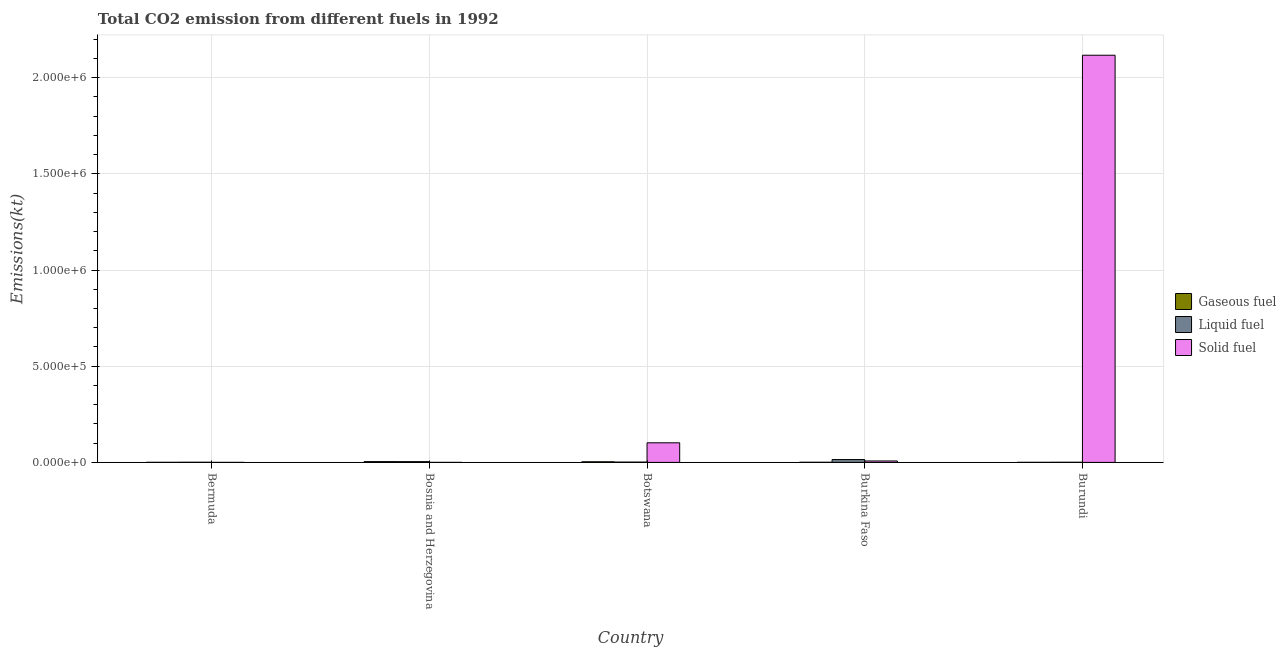How many different coloured bars are there?
Your answer should be very brief. 3. How many groups of bars are there?
Your answer should be very brief. 5. What is the label of the 3rd group of bars from the left?
Your answer should be very brief. Botswana. In how many cases, is the number of bars for a given country not equal to the number of legend labels?
Your answer should be compact. 0. What is the amount of co2 emissions from gaseous fuel in Burkina Faso?
Keep it short and to the point. 630.72. Across all countries, what is the maximum amount of co2 emissions from liquid fuel?
Offer a very short reply. 1.48e+04. Across all countries, what is the minimum amount of co2 emissions from liquid fuel?
Your response must be concise. 630.72. In which country was the amount of co2 emissions from gaseous fuel maximum?
Offer a very short reply. Bosnia and Herzegovina. In which country was the amount of co2 emissions from solid fuel minimum?
Give a very brief answer. Bosnia and Herzegovina. What is the total amount of co2 emissions from liquid fuel in the graph?
Keep it short and to the point. 2.17e+04. What is the difference between the amount of co2 emissions from gaseous fuel in Botswana and that in Burundi?
Your answer should be compact. 2966.6. What is the difference between the amount of co2 emissions from gaseous fuel in Bermuda and the amount of co2 emissions from liquid fuel in Botswana?
Offer a very short reply. -1188.11. What is the average amount of co2 emissions from liquid fuel per country?
Provide a succinct answer. 4331.46. What is the difference between the amount of co2 emissions from liquid fuel and amount of co2 emissions from solid fuel in Burundi?
Offer a very short reply. -2.12e+06. In how many countries, is the amount of co2 emissions from liquid fuel greater than 900000 kt?
Provide a short and direct response. 0. What is the ratio of the amount of co2 emissions from liquid fuel in Botswana to that in Burkina Faso?
Your answer should be compact. 0.11. Is the difference between the amount of co2 emissions from gaseous fuel in Bermuda and Burundi greater than the difference between the amount of co2 emissions from liquid fuel in Bermuda and Burundi?
Offer a very short reply. Yes. What is the difference between the highest and the second highest amount of co2 emissions from liquid fuel?
Your answer should be very brief. 1.08e+04. What is the difference between the highest and the lowest amount of co2 emissions from solid fuel?
Your response must be concise. 2.12e+06. In how many countries, is the amount of co2 emissions from gaseous fuel greater than the average amount of co2 emissions from gaseous fuel taken over all countries?
Provide a short and direct response. 2. What does the 1st bar from the left in Burundi represents?
Provide a short and direct response. Gaseous fuel. What does the 2nd bar from the right in Bermuda represents?
Offer a terse response. Liquid fuel. Is it the case that in every country, the sum of the amount of co2 emissions from gaseous fuel and amount of co2 emissions from liquid fuel is greater than the amount of co2 emissions from solid fuel?
Offer a very short reply. No. How many countries are there in the graph?
Keep it short and to the point. 5. What is the difference between two consecutive major ticks on the Y-axis?
Offer a terse response. 5.00e+05. Does the graph contain any zero values?
Your answer should be compact. No. Where does the legend appear in the graph?
Keep it short and to the point. Center right. How are the legend labels stacked?
Offer a very short reply. Vertical. What is the title of the graph?
Keep it short and to the point. Total CO2 emission from different fuels in 1992. Does "Ages 0-14" appear as one of the legend labels in the graph?
Offer a terse response. No. What is the label or title of the Y-axis?
Provide a short and direct response. Emissions(kt). What is the Emissions(kt) in Gaseous fuel in Bermuda?
Provide a short and direct response. 407.04. What is the Emissions(kt) in Liquid fuel in Bermuda?
Offer a very short reply. 722.4. What is the Emissions(kt) in Solid fuel in Bermuda?
Ensure brevity in your answer.  18.34. What is the Emissions(kt) of Gaseous fuel in Bosnia and Herzegovina?
Keep it short and to the point. 4136.38. What is the Emissions(kt) of Liquid fuel in Bosnia and Herzegovina?
Offer a very short reply. 3949.36. What is the Emissions(kt) in Solid fuel in Bosnia and Herzegovina?
Provide a succinct answer. 3.67. What is the Emissions(kt) of Gaseous fuel in Botswana?
Your answer should be very brief. 3274.63. What is the Emissions(kt) of Liquid fuel in Botswana?
Make the answer very short. 1595.14. What is the Emissions(kt) of Solid fuel in Botswana?
Your response must be concise. 1.02e+05. What is the Emissions(kt) of Gaseous fuel in Burkina Faso?
Your answer should be compact. 630.72. What is the Emissions(kt) in Liquid fuel in Burkina Faso?
Ensure brevity in your answer.  1.48e+04. What is the Emissions(kt) of Solid fuel in Burkina Faso?
Offer a very short reply. 7462.35. What is the Emissions(kt) in Gaseous fuel in Burundi?
Give a very brief answer. 308.03. What is the Emissions(kt) of Liquid fuel in Burundi?
Make the answer very short. 630.72. What is the Emissions(kt) of Solid fuel in Burundi?
Your answer should be compact. 2.12e+06. Across all countries, what is the maximum Emissions(kt) of Gaseous fuel?
Offer a terse response. 4136.38. Across all countries, what is the maximum Emissions(kt) of Liquid fuel?
Keep it short and to the point. 1.48e+04. Across all countries, what is the maximum Emissions(kt) of Solid fuel?
Give a very brief answer. 2.12e+06. Across all countries, what is the minimum Emissions(kt) of Gaseous fuel?
Keep it short and to the point. 308.03. Across all countries, what is the minimum Emissions(kt) of Liquid fuel?
Offer a terse response. 630.72. Across all countries, what is the minimum Emissions(kt) in Solid fuel?
Give a very brief answer. 3.67. What is the total Emissions(kt) of Gaseous fuel in the graph?
Your answer should be compact. 8756.8. What is the total Emissions(kt) of Liquid fuel in the graph?
Give a very brief answer. 2.17e+04. What is the total Emissions(kt) in Solid fuel in the graph?
Your response must be concise. 2.23e+06. What is the difference between the Emissions(kt) in Gaseous fuel in Bermuda and that in Bosnia and Herzegovina?
Offer a terse response. -3729.34. What is the difference between the Emissions(kt) in Liquid fuel in Bermuda and that in Bosnia and Herzegovina?
Your answer should be compact. -3226.96. What is the difference between the Emissions(kt) in Solid fuel in Bermuda and that in Bosnia and Herzegovina?
Your answer should be compact. 14.67. What is the difference between the Emissions(kt) in Gaseous fuel in Bermuda and that in Botswana?
Provide a succinct answer. -2867.59. What is the difference between the Emissions(kt) in Liquid fuel in Bermuda and that in Botswana?
Ensure brevity in your answer.  -872.75. What is the difference between the Emissions(kt) of Solid fuel in Bermuda and that in Botswana?
Your answer should be very brief. -1.02e+05. What is the difference between the Emissions(kt) in Gaseous fuel in Bermuda and that in Burkina Faso?
Offer a terse response. -223.69. What is the difference between the Emissions(kt) of Liquid fuel in Bermuda and that in Burkina Faso?
Keep it short and to the point. -1.40e+04. What is the difference between the Emissions(kt) of Solid fuel in Bermuda and that in Burkina Faso?
Your response must be concise. -7444.01. What is the difference between the Emissions(kt) of Gaseous fuel in Bermuda and that in Burundi?
Offer a very short reply. 99.01. What is the difference between the Emissions(kt) in Liquid fuel in Bermuda and that in Burundi?
Offer a very short reply. 91.67. What is the difference between the Emissions(kt) in Solid fuel in Bermuda and that in Burundi?
Provide a succinct answer. -2.12e+06. What is the difference between the Emissions(kt) in Gaseous fuel in Bosnia and Herzegovina and that in Botswana?
Give a very brief answer. 861.75. What is the difference between the Emissions(kt) of Liquid fuel in Bosnia and Herzegovina and that in Botswana?
Your answer should be compact. 2354.21. What is the difference between the Emissions(kt) in Solid fuel in Bosnia and Herzegovina and that in Botswana?
Make the answer very short. -1.02e+05. What is the difference between the Emissions(kt) in Gaseous fuel in Bosnia and Herzegovina and that in Burkina Faso?
Your answer should be very brief. 3505.65. What is the difference between the Emissions(kt) in Liquid fuel in Bosnia and Herzegovina and that in Burkina Faso?
Ensure brevity in your answer.  -1.08e+04. What is the difference between the Emissions(kt) of Solid fuel in Bosnia and Herzegovina and that in Burkina Faso?
Ensure brevity in your answer.  -7458.68. What is the difference between the Emissions(kt) of Gaseous fuel in Bosnia and Herzegovina and that in Burundi?
Your response must be concise. 3828.35. What is the difference between the Emissions(kt) of Liquid fuel in Bosnia and Herzegovina and that in Burundi?
Your answer should be very brief. 3318.64. What is the difference between the Emissions(kt) in Solid fuel in Bosnia and Herzegovina and that in Burundi?
Offer a terse response. -2.12e+06. What is the difference between the Emissions(kt) in Gaseous fuel in Botswana and that in Burkina Faso?
Offer a very short reply. 2643.91. What is the difference between the Emissions(kt) of Liquid fuel in Botswana and that in Burkina Faso?
Keep it short and to the point. -1.32e+04. What is the difference between the Emissions(kt) of Solid fuel in Botswana and that in Burkina Faso?
Provide a succinct answer. 9.44e+04. What is the difference between the Emissions(kt) of Gaseous fuel in Botswana and that in Burundi?
Provide a succinct answer. 2966.6. What is the difference between the Emissions(kt) in Liquid fuel in Botswana and that in Burundi?
Keep it short and to the point. 964.42. What is the difference between the Emissions(kt) in Solid fuel in Botswana and that in Burundi?
Your response must be concise. -2.01e+06. What is the difference between the Emissions(kt) in Gaseous fuel in Burkina Faso and that in Burundi?
Your answer should be very brief. 322.7. What is the difference between the Emissions(kt) of Liquid fuel in Burkina Faso and that in Burundi?
Ensure brevity in your answer.  1.41e+04. What is the difference between the Emissions(kt) of Solid fuel in Burkina Faso and that in Burundi?
Provide a short and direct response. -2.11e+06. What is the difference between the Emissions(kt) in Gaseous fuel in Bermuda and the Emissions(kt) in Liquid fuel in Bosnia and Herzegovina?
Offer a terse response. -3542.32. What is the difference between the Emissions(kt) of Gaseous fuel in Bermuda and the Emissions(kt) of Solid fuel in Bosnia and Herzegovina?
Make the answer very short. 403.37. What is the difference between the Emissions(kt) of Liquid fuel in Bermuda and the Emissions(kt) of Solid fuel in Bosnia and Herzegovina?
Your answer should be very brief. 718.73. What is the difference between the Emissions(kt) in Gaseous fuel in Bermuda and the Emissions(kt) in Liquid fuel in Botswana?
Make the answer very short. -1188.11. What is the difference between the Emissions(kt) of Gaseous fuel in Bermuda and the Emissions(kt) of Solid fuel in Botswana?
Give a very brief answer. -1.01e+05. What is the difference between the Emissions(kt) in Liquid fuel in Bermuda and the Emissions(kt) in Solid fuel in Botswana?
Your response must be concise. -1.01e+05. What is the difference between the Emissions(kt) in Gaseous fuel in Bermuda and the Emissions(kt) in Liquid fuel in Burkina Faso?
Offer a terse response. -1.44e+04. What is the difference between the Emissions(kt) of Gaseous fuel in Bermuda and the Emissions(kt) of Solid fuel in Burkina Faso?
Your answer should be compact. -7055.31. What is the difference between the Emissions(kt) in Liquid fuel in Bermuda and the Emissions(kt) in Solid fuel in Burkina Faso?
Ensure brevity in your answer.  -6739.95. What is the difference between the Emissions(kt) of Gaseous fuel in Bermuda and the Emissions(kt) of Liquid fuel in Burundi?
Offer a very short reply. -223.69. What is the difference between the Emissions(kt) of Gaseous fuel in Bermuda and the Emissions(kt) of Solid fuel in Burundi?
Offer a very short reply. -2.12e+06. What is the difference between the Emissions(kt) in Liquid fuel in Bermuda and the Emissions(kt) in Solid fuel in Burundi?
Provide a succinct answer. -2.12e+06. What is the difference between the Emissions(kt) in Gaseous fuel in Bosnia and Herzegovina and the Emissions(kt) in Liquid fuel in Botswana?
Provide a short and direct response. 2541.23. What is the difference between the Emissions(kt) in Gaseous fuel in Bosnia and Herzegovina and the Emissions(kt) in Solid fuel in Botswana?
Make the answer very short. -9.77e+04. What is the difference between the Emissions(kt) in Liquid fuel in Bosnia and Herzegovina and the Emissions(kt) in Solid fuel in Botswana?
Your response must be concise. -9.79e+04. What is the difference between the Emissions(kt) in Gaseous fuel in Bosnia and Herzegovina and the Emissions(kt) in Liquid fuel in Burkina Faso?
Your answer should be compact. -1.06e+04. What is the difference between the Emissions(kt) of Gaseous fuel in Bosnia and Herzegovina and the Emissions(kt) of Solid fuel in Burkina Faso?
Your answer should be very brief. -3325.97. What is the difference between the Emissions(kt) in Liquid fuel in Bosnia and Herzegovina and the Emissions(kt) in Solid fuel in Burkina Faso?
Your answer should be compact. -3512.99. What is the difference between the Emissions(kt) of Gaseous fuel in Bosnia and Herzegovina and the Emissions(kt) of Liquid fuel in Burundi?
Give a very brief answer. 3505.65. What is the difference between the Emissions(kt) of Gaseous fuel in Bosnia and Herzegovina and the Emissions(kt) of Solid fuel in Burundi?
Ensure brevity in your answer.  -2.11e+06. What is the difference between the Emissions(kt) of Liquid fuel in Bosnia and Herzegovina and the Emissions(kt) of Solid fuel in Burundi?
Give a very brief answer. -2.11e+06. What is the difference between the Emissions(kt) of Gaseous fuel in Botswana and the Emissions(kt) of Liquid fuel in Burkina Faso?
Your answer should be compact. -1.15e+04. What is the difference between the Emissions(kt) in Gaseous fuel in Botswana and the Emissions(kt) in Solid fuel in Burkina Faso?
Your answer should be very brief. -4187.71. What is the difference between the Emissions(kt) of Liquid fuel in Botswana and the Emissions(kt) of Solid fuel in Burkina Faso?
Keep it short and to the point. -5867.2. What is the difference between the Emissions(kt) in Gaseous fuel in Botswana and the Emissions(kt) in Liquid fuel in Burundi?
Your answer should be very brief. 2643.91. What is the difference between the Emissions(kt) of Gaseous fuel in Botswana and the Emissions(kt) of Solid fuel in Burundi?
Provide a short and direct response. -2.11e+06. What is the difference between the Emissions(kt) in Liquid fuel in Botswana and the Emissions(kt) in Solid fuel in Burundi?
Provide a short and direct response. -2.11e+06. What is the difference between the Emissions(kt) in Gaseous fuel in Burkina Faso and the Emissions(kt) in Solid fuel in Burundi?
Ensure brevity in your answer.  -2.12e+06. What is the difference between the Emissions(kt) of Liquid fuel in Burkina Faso and the Emissions(kt) of Solid fuel in Burundi?
Make the answer very short. -2.10e+06. What is the average Emissions(kt) of Gaseous fuel per country?
Offer a very short reply. 1751.36. What is the average Emissions(kt) of Liquid fuel per country?
Keep it short and to the point. 4331.46. What is the average Emissions(kt) in Solid fuel per country?
Provide a short and direct response. 4.45e+05. What is the difference between the Emissions(kt) in Gaseous fuel and Emissions(kt) in Liquid fuel in Bermuda?
Give a very brief answer. -315.36. What is the difference between the Emissions(kt) in Gaseous fuel and Emissions(kt) in Solid fuel in Bermuda?
Your answer should be compact. 388.7. What is the difference between the Emissions(kt) of Liquid fuel and Emissions(kt) of Solid fuel in Bermuda?
Offer a terse response. 704.06. What is the difference between the Emissions(kt) of Gaseous fuel and Emissions(kt) of Liquid fuel in Bosnia and Herzegovina?
Ensure brevity in your answer.  187.02. What is the difference between the Emissions(kt) in Gaseous fuel and Emissions(kt) in Solid fuel in Bosnia and Herzegovina?
Ensure brevity in your answer.  4132.71. What is the difference between the Emissions(kt) in Liquid fuel and Emissions(kt) in Solid fuel in Bosnia and Herzegovina?
Your answer should be compact. 3945.69. What is the difference between the Emissions(kt) of Gaseous fuel and Emissions(kt) of Liquid fuel in Botswana?
Make the answer very short. 1679.49. What is the difference between the Emissions(kt) in Gaseous fuel and Emissions(kt) in Solid fuel in Botswana?
Your response must be concise. -9.86e+04. What is the difference between the Emissions(kt) in Liquid fuel and Emissions(kt) in Solid fuel in Botswana?
Your response must be concise. -1.00e+05. What is the difference between the Emissions(kt) of Gaseous fuel and Emissions(kt) of Liquid fuel in Burkina Faso?
Provide a short and direct response. -1.41e+04. What is the difference between the Emissions(kt) of Gaseous fuel and Emissions(kt) of Solid fuel in Burkina Faso?
Offer a very short reply. -6831.62. What is the difference between the Emissions(kt) of Liquid fuel and Emissions(kt) of Solid fuel in Burkina Faso?
Keep it short and to the point. 7297.33. What is the difference between the Emissions(kt) of Gaseous fuel and Emissions(kt) of Liquid fuel in Burundi?
Offer a very short reply. -322.7. What is the difference between the Emissions(kt) in Gaseous fuel and Emissions(kt) in Solid fuel in Burundi?
Give a very brief answer. -2.12e+06. What is the difference between the Emissions(kt) in Liquid fuel and Emissions(kt) in Solid fuel in Burundi?
Ensure brevity in your answer.  -2.12e+06. What is the ratio of the Emissions(kt) of Gaseous fuel in Bermuda to that in Bosnia and Herzegovina?
Offer a very short reply. 0.1. What is the ratio of the Emissions(kt) in Liquid fuel in Bermuda to that in Bosnia and Herzegovina?
Provide a succinct answer. 0.18. What is the ratio of the Emissions(kt) in Solid fuel in Bermuda to that in Bosnia and Herzegovina?
Offer a very short reply. 5. What is the ratio of the Emissions(kt) in Gaseous fuel in Bermuda to that in Botswana?
Your answer should be compact. 0.12. What is the ratio of the Emissions(kt) in Liquid fuel in Bermuda to that in Botswana?
Provide a succinct answer. 0.45. What is the ratio of the Emissions(kt) in Gaseous fuel in Bermuda to that in Burkina Faso?
Keep it short and to the point. 0.65. What is the ratio of the Emissions(kt) in Liquid fuel in Bermuda to that in Burkina Faso?
Keep it short and to the point. 0.05. What is the ratio of the Emissions(kt) in Solid fuel in Bermuda to that in Burkina Faso?
Give a very brief answer. 0. What is the ratio of the Emissions(kt) of Gaseous fuel in Bermuda to that in Burundi?
Your answer should be compact. 1.32. What is the ratio of the Emissions(kt) of Liquid fuel in Bermuda to that in Burundi?
Your response must be concise. 1.15. What is the ratio of the Emissions(kt) of Solid fuel in Bermuda to that in Burundi?
Give a very brief answer. 0. What is the ratio of the Emissions(kt) in Gaseous fuel in Bosnia and Herzegovina to that in Botswana?
Give a very brief answer. 1.26. What is the ratio of the Emissions(kt) of Liquid fuel in Bosnia and Herzegovina to that in Botswana?
Provide a succinct answer. 2.48. What is the ratio of the Emissions(kt) of Gaseous fuel in Bosnia and Herzegovina to that in Burkina Faso?
Your answer should be compact. 6.56. What is the ratio of the Emissions(kt) of Liquid fuel in Bosnia and Herzegovina to that in Burkina Faso?
Offer a very short reply. 0.27. What is the ratio of the Emissions(kt) in Gaseous fuel in Bosnia and Herzegovina to that in Burundi?
Make the answer very short. 13.43. What is the ratio of the Emissions(kt) of Liquid fuel in Bosnia and Herzegovina to that in Burundi?
Give a very brief answer. 6.26. What is the ratio of the Emissions(kt) of Solid fuel in Bosnia and Herzegovina to that in Burundi?
Provide a succinct answer. 0. What is the ratio of the Emissions(kt) of Gaseous fuel in Botswana to that in Burkina Faso?
Your response must be concise. 5.19. What is the ratio of the Emissions(kt) in Liquid fuel in Botswana to that in Burkina Faso?
Give a very brief answer. 0.11. What is the ratio of the Emissions(kt) in Solid fuel in Botswana to that in Burkina Faso?
Your response must be concise. 13.65. What is the ratio of the Emissions(kt) in Gaseous fuel in Botswana to that in Burundi?
Ensure brevity in your answer.  10.63. What is the ratio of the Emissions(kt) of Liquid fuel in Botswana to that in Burundi?
Offer a terse response. 2.53. What is the ratio of the Emissions(kt) of Solid fuel in Botswana to that in Burundi?
Offer a terse response. 0.05. What is the ratio of the Emissions(kt) of Gaseous fuel in Burkina Faso to that in Burundi?
Offer a terse response. 2.05. What is the ratio of the Emissions(kt) in Liquid fuel in Burkina Faso to that in Burundi?
Give a very brief answer. 23.4. What is the ratio of the Emissions(kt) in Solid fuel in Burkina Faso to that in Burundi?
Ensure brevity in your answer.  0. What is the difference between the highest and the second highest Emissions(kt) of Gaseous fuel?
Offer a very short reply. 861.75. What is the difference between the highest and the second highest Emissions(kt) in Liquid fuel?
Your response must be concise. 1.08e+04. What is the difference between the highest and the second highest Emissions(kt) of Solid fuel?
Ensure brevity in your answer.  2.01e+06. What is the difference between the highest and the lowest Emissions(kt) of Gaseous fuel?
Keep it short and to the point. 3828.35. What is the difference between the highest and the lowest Emissions(kt) in Liquid fuel?
Provide a short and direct response. 1.41e+04. What is the difference between the highest and the lowest Emissions(kt) of Solid fuel?
Your answer should be very brief. 2.12e+06. 